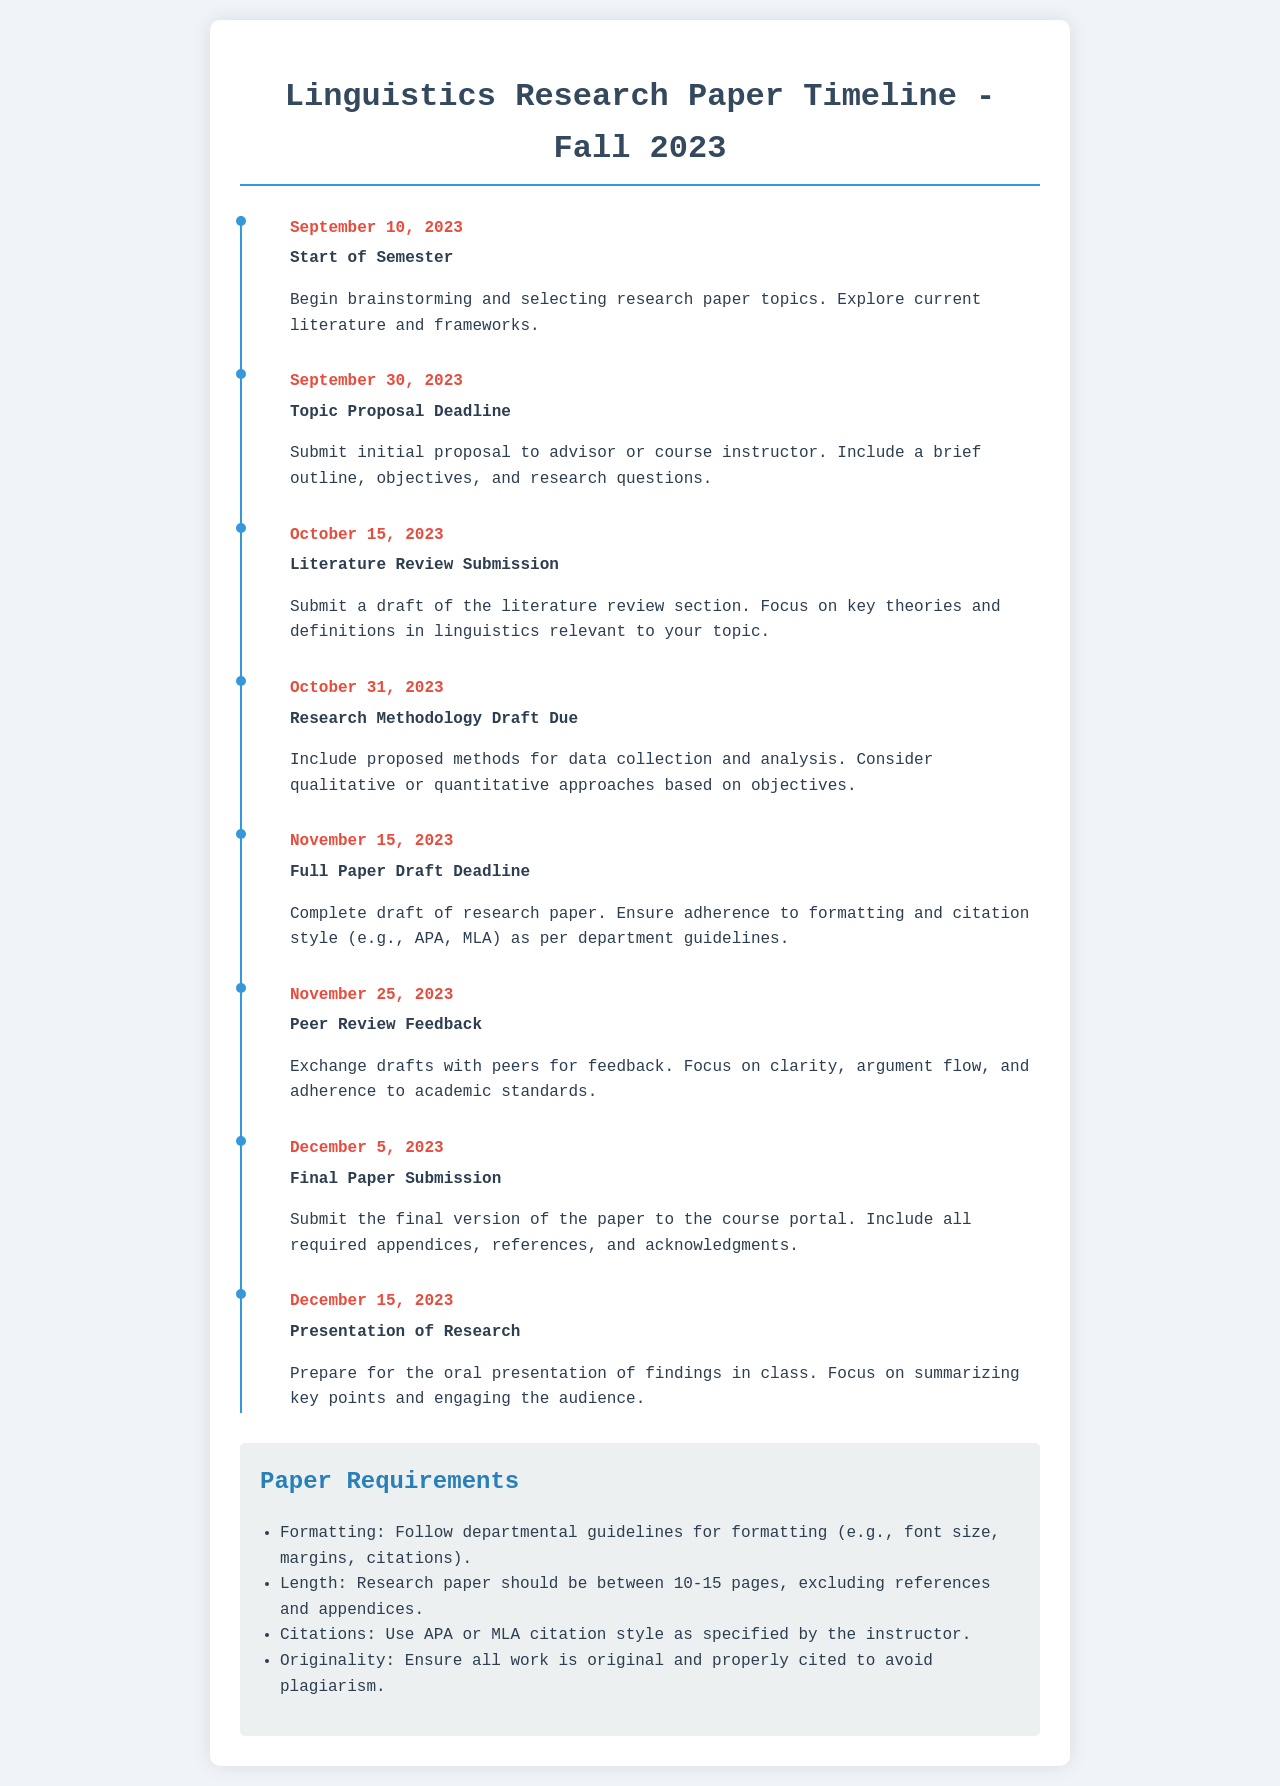What is the topic proposal deadline? The topic proposal deadline is specified as the date when the initial proposal must be submitted, which is September 30, 2023.
Answer: September 30, 2023 When is the final paper submission due? The final paper submission due date is the last deadline mentioned in the timeline for the semester, which is December 5, 2023.
Answer: December 5, 2023 What is the length requirement for the research paper? The document clearly states that the research paper should be between 10-15 pages, excluding references and appendices.
Answer: 10-15 pages On what date does the semester start? The start date for the semester is noted in the first event of the timeline, which is specified as September 10, 2023.
Answer: September 10, 2023 How many days after the literature review submission is the research methodology draft due? To find this, we calculate the days between the two specified dates, October 15, 2023 and October 31, 2023, which is 16 days.
Answer: 16 days What type of feedback is to be given on November 25, 2023? The event on November 25, 2023, refers to exchanging drafts with peers for feedback, which is focused on clarity, argument flow, and adherence to academic standards.
Answer: Peer Review Feedback What is the final task noted for December 15, 2023? The last task in the timeline is the preparation for the oral presentation of findings, which is emphasized on summarizing key points and engaging the audience.
Answer: Presentation of Research What citation styles are acceptable for the paper? The requirements section specifies two citation styles, APA and MLA, as acceptable for the research paper based on instructor specifications.
Answer: APA or MLA 